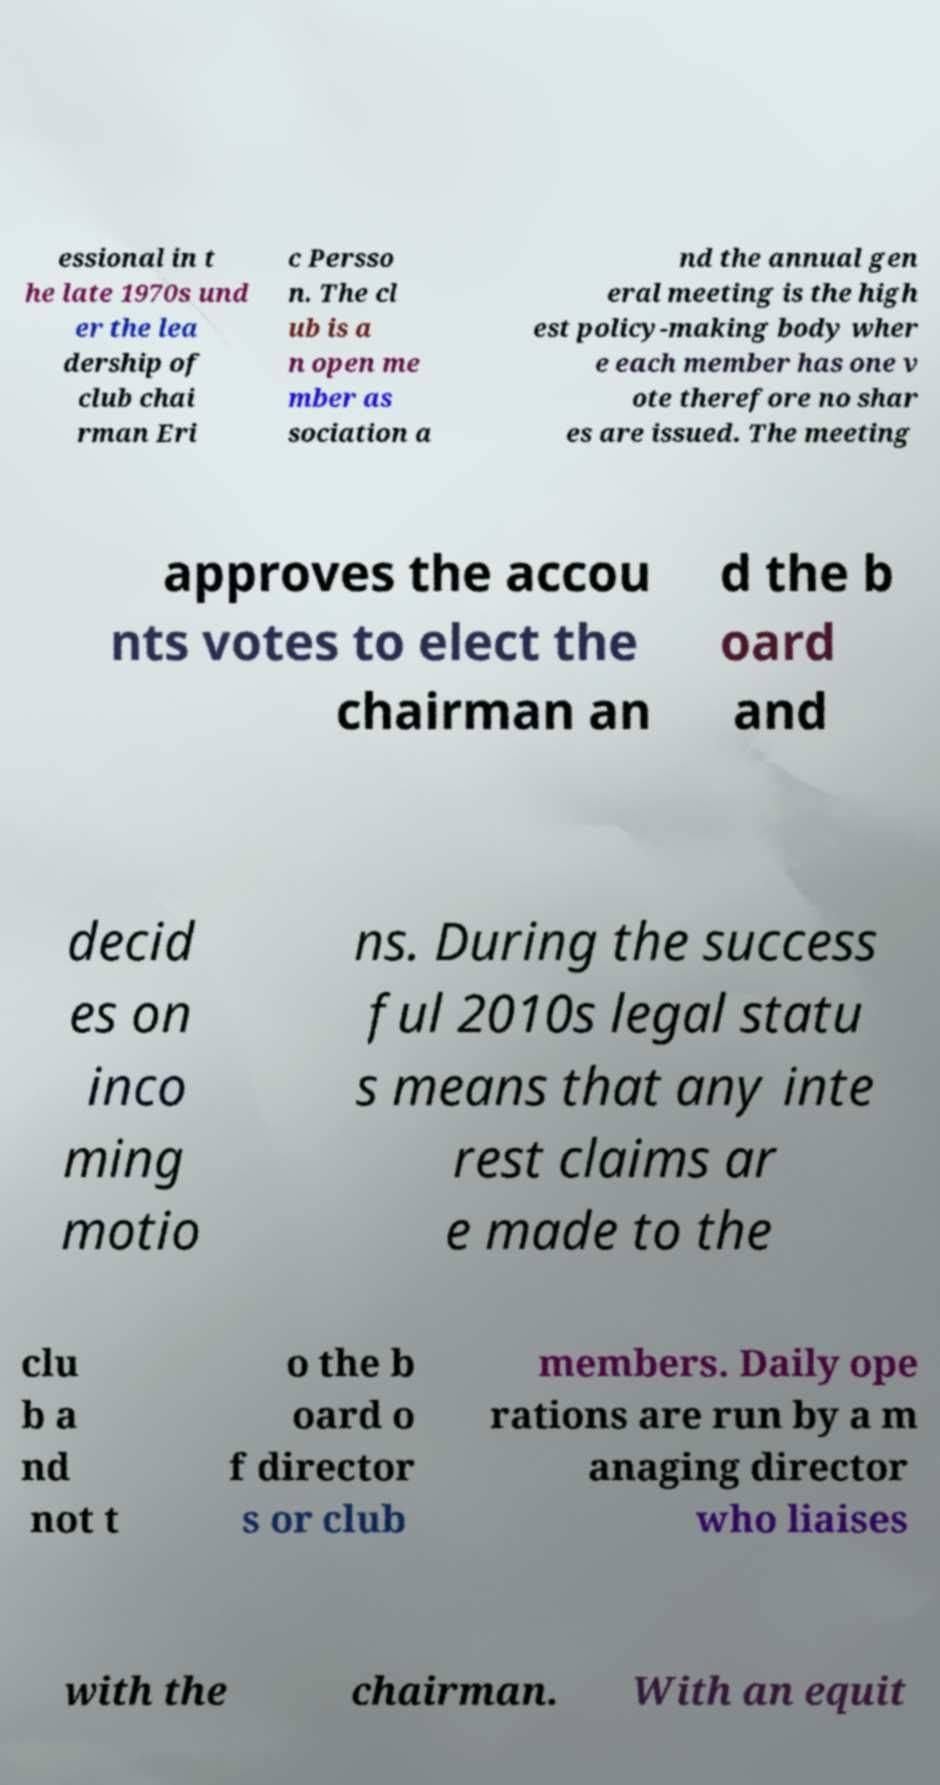For documentation purposes, I need the text within this image transcribed. Could you provide that? essional in t he late 1970s und er the lea dership of club chai rman Eri c Persso n. The cl ub is a n open me mber as sociation a nd the annual gen eral meeting is the high est policy-making body wher e each member has one v ote therefore no shar es are issued. The meeting approves the accou nts votes to elect the chairman an d the b oard and decid es on inco ming motio ns. During the success ful 2010s legal statu s means that any inte rest claims ar e made to the clu b a nd not t o the b oard o f director s or club members. Daily ope rations are run by a m anaging director who liaises with the chairman. With an equit 